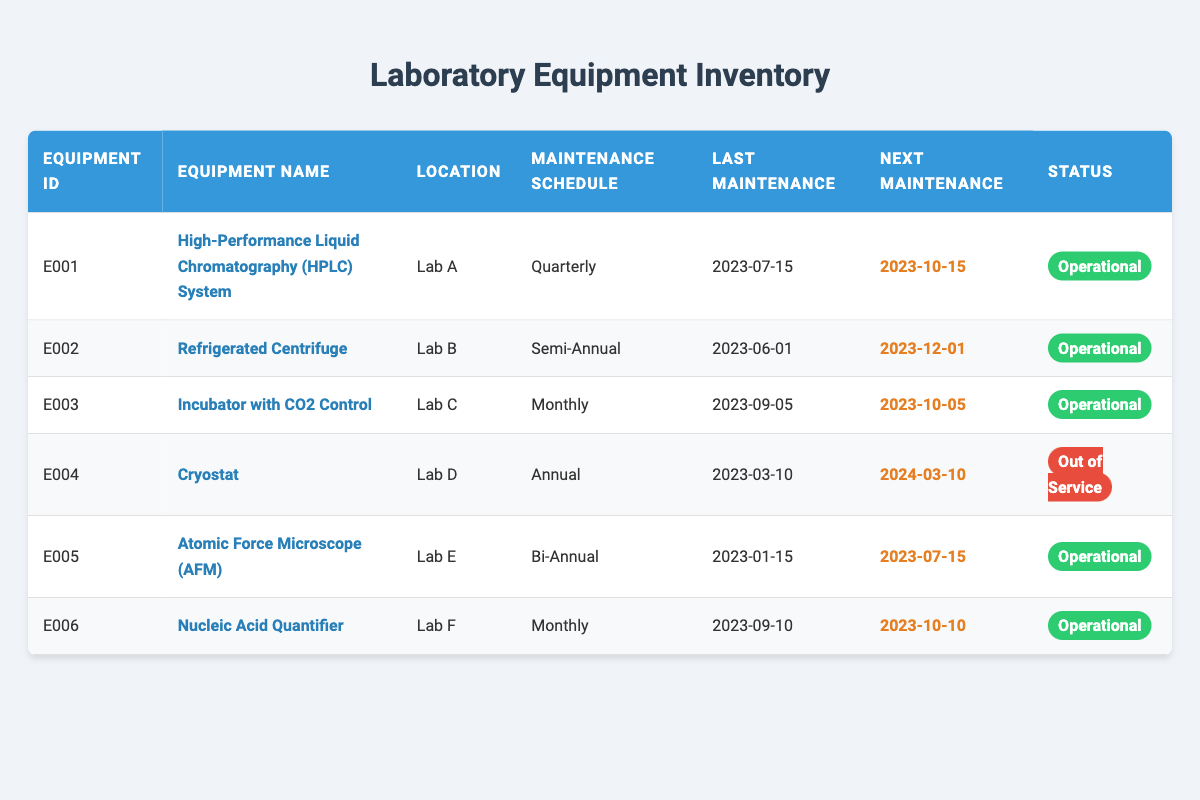What is the maintenance schedule for the Atomic Force Microscope (AFM)? The Atomic Force Microscope (AFM) is listed in the table, and its maintenance schedule is clearly stated as "Bi-Annual."
Answer: Bi-Annual Which equipment has the next maintenance due date? By scanning the "Next Maintenance Due" column, the earliest date listed is "2023-10-05" for the Incubator with CO2 Control. Thus, this equipment has the next maintenance due.
Answer: Incubator with CO2 Control Is the Cryostat operational? The status of the Cryostat in the "Status" column shows "Out of Service," indicating that it is not operational.
Answer: No How many pieces of equipment have a maintenance schedule of "Monthly"? From the inventory, both the "Incubator with CO2 Control" and "Nucleic Acid Quantifier" have a maintenance schedule of "Monthly," totaling two pieces of equipment.
Answer: 2 If we calculate how many pieces of equipment are operational versus out of service, how many are operational? By reviewing the "Status" column, five pieces of equipment are marked as "Operational" (HPLC System, Refrigerated Centrifuge, Incubator with CO2 Control, Atomic Force Microscope, and Nucleic Acid Quantifier), while only one (Cryostat) is out of service. Thus, the result is five operational pieces.
Answer: 5 What is the last maintenance date for the Refrigerated Centrifuge? The last maintenance date for the Refrigerated Centrifuge can be found in the "Last Maintenance" column, which indicates that the date is "2023-06-01."
Answer: 2023-06-01 Based on the current data, which equipment needs maintenance sooner: the High-Performance Liquid Chromatography (HPLC) System or the Nucleic Acid Quantifier? The High-Performance Liquid Chromatography (HPLC) System's next maintenance is due on "2023-10-15," while the Nucleic Acid Quantifier's next maintenance is due on "2023-10-10." Since 10-10 is earlier, the Nucleic Acid Quantifier needs maintenance sooner.
Answer: Nucleic Acid Quantifier What is the status of the equipment located in Lab D? The equipment located in Lab D is the Cryostat, and its status is listed as "Out of Service" according to the "Status" column.
Answer: Out of Service How many equipment have their next maintenance due in the year 2023? By examining the "Next Maintenance Due" column, I can identify that three pieces of equipment (HPLC System, Refrigerated Centrifuge, and Incubator with CO2 Control) have their next maintenance due in 2023, with their respective due dates falling within that year.
Answer: 3 